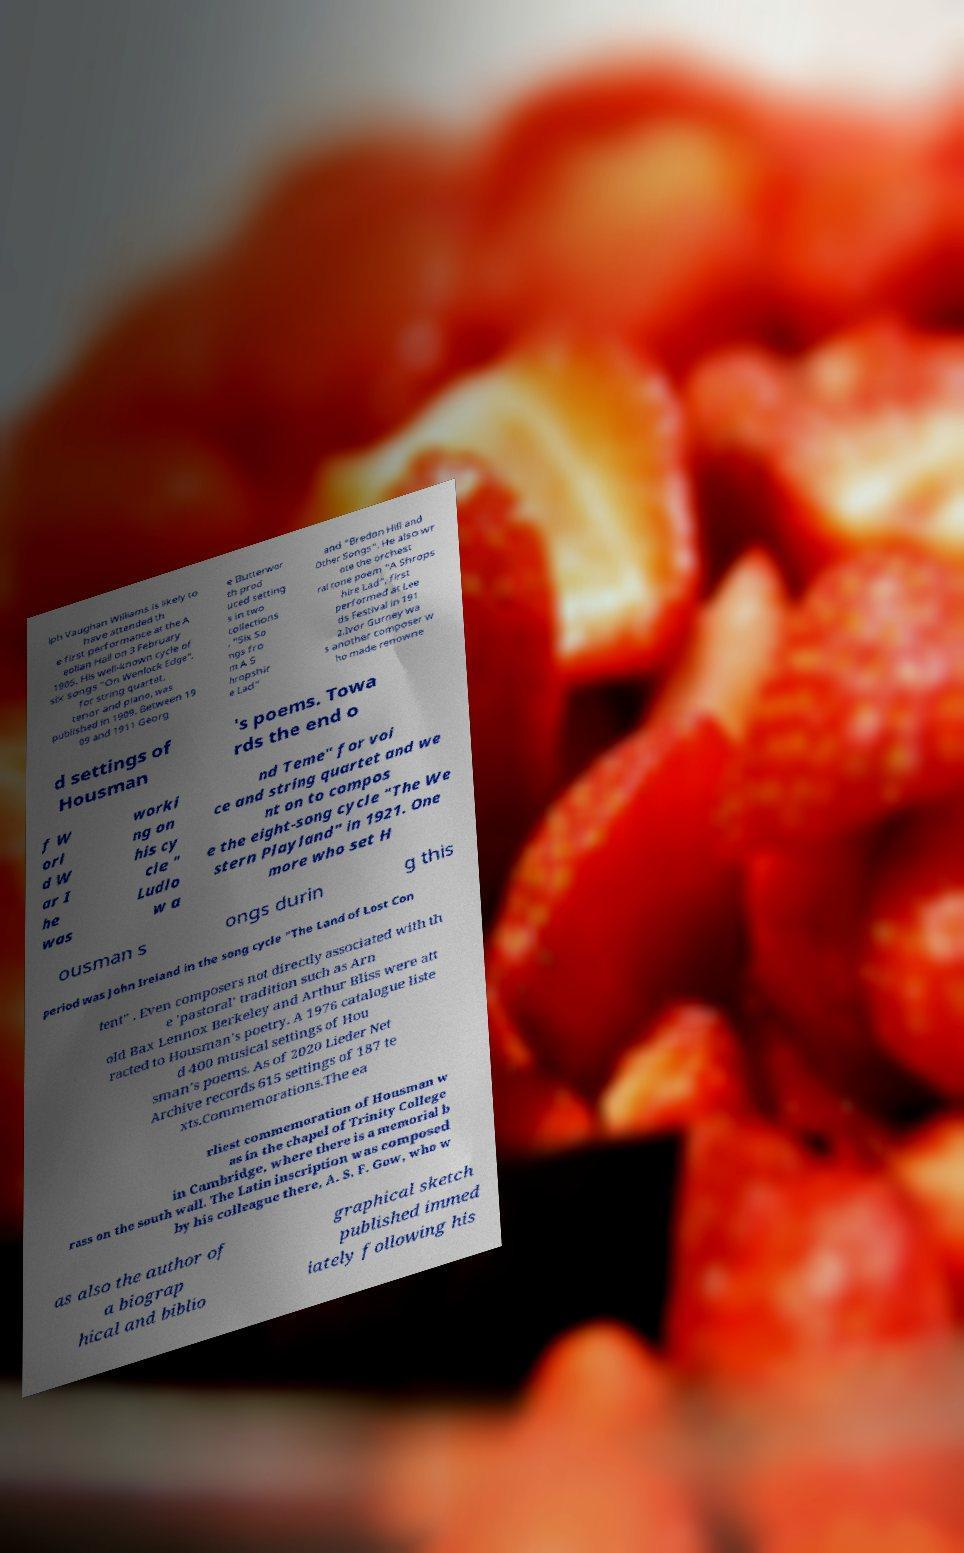Can you read and provide the text displayed in the image?This photo seems to have some interesting text. Can you extract and type it out for me? lph Vaughan Williams is likely to have attended th e first performance at the A eolian Hall on 3 February 1905. His well-known cycle of six songs "On Wenlock Edge", for string quartet, tenor and piano, was published in 1909. Between 19 09 and 1911 Georg e Butterwor th prod uced setting s in two collections , "Six So ngs fro m A S hropshir e Lad" and "Bredon Hill and Other Songs". He also wr ote the orchest ral tone poem "A Shrops hire Lad", first performed at Lee ds Festival in 191 2.Ivor Gurney wa s another composer w ho made renowne d settings of Housman 's poems. Towa rds the end o f W orl d W ar I he was worki ng on his cy cle " Ludlo w a nd Teme" for voi ce and string quartet and we nt on to compos e the eight-song cycle "The We stern Playland" in 1921. One more who set H ousman s ongs durin g this period was John Ireland in the song cycle "The Land of Lost Con tent" . Even composers not directly associated with th e 'pastoral' tradition such as Arn old Bax Lennox Berkeley and Arthur Bliss were att racted to Housman's poetry. A 1976 catalogue liste d 400 musical settings of Hou sman's poems. As of 2020 Lieder Net Archive records 615 settings of 187 te xts.Commemorations.The ea rliest commemoration of Housman w as in the chapel of Trinity College in Cambridge, where there is a memorial b rass on the south wall. The Latin inscription was composed by his colleague there, A. S. F. Gow, who w as also the author of a biograp hical and biblio graphical sketch published immed iately following his 